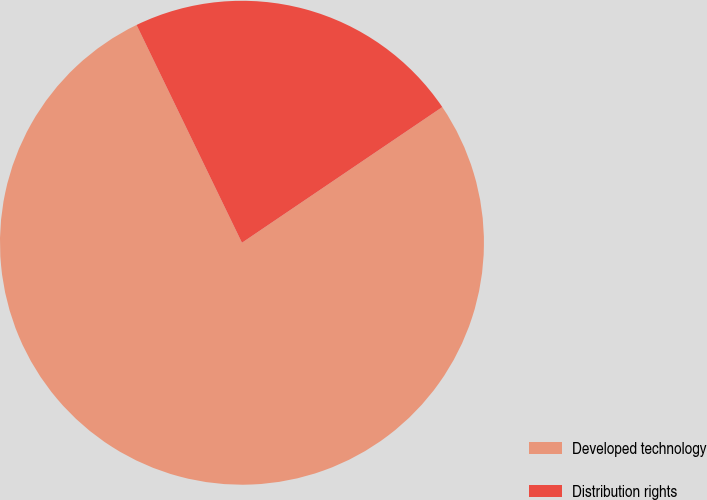Convert chart. <chart><loc_0><loc_0><loc_500><loc_500><pie_chart><fcel>Developed technology<fcel>Distribution rights<nl><fcel>77.3%<fcel>22.7%<nl></chart> 